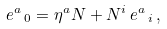<formula> <loc_0><loc_0><loc_500><loc_500>e ^ { a } \, _ { 0 } = \eta ^ { a } N + N ^ { i } \, e ^ { a } \, _ { i } \, ,</formula> 